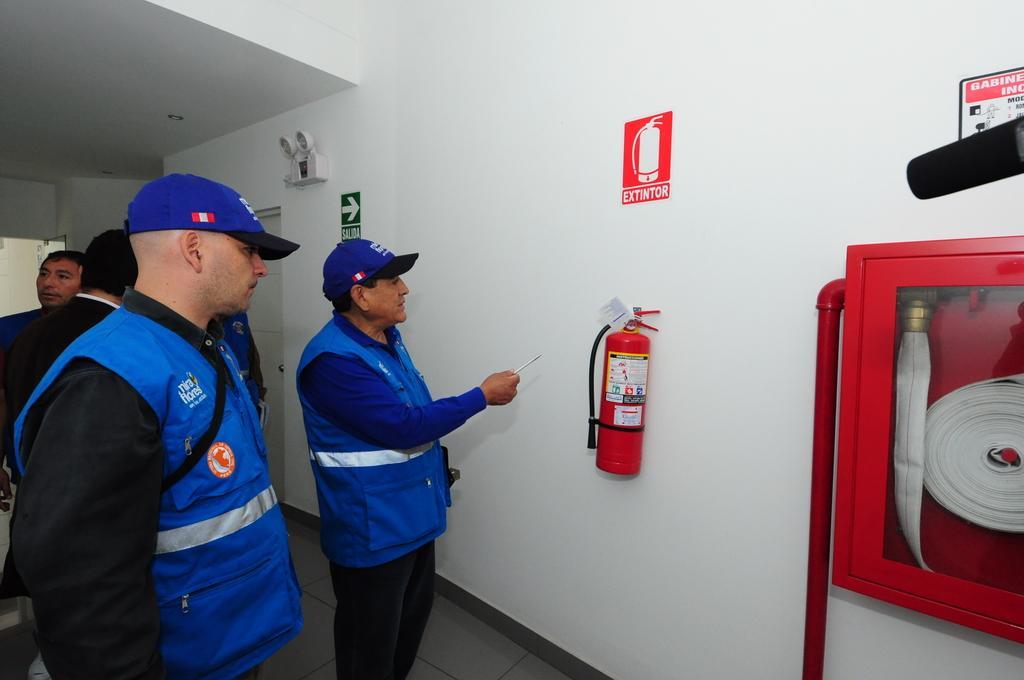How would you summarize this image in a sentence or two? In this picture i see few people standing and I see a fire extinguisher and few boards on the wall and a glass box on the right side to the wall and i see couple of men wore caps on their heads. 